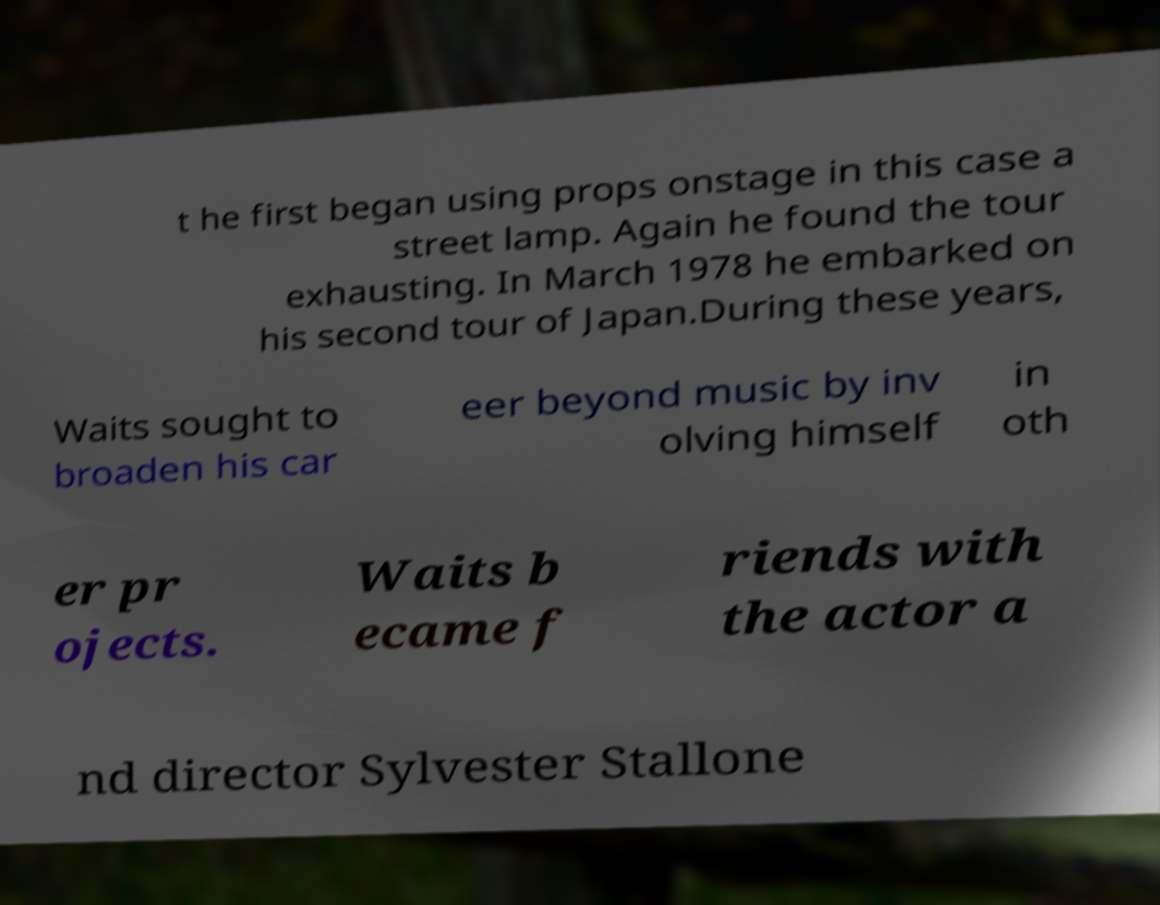For documentation purposes, I need the text within this image transcribed. Could you provide that? t he first began using props onstage in this case a street lamp. Again he found the tour exhausting. In March 1978 he embarked on his second tour of Japan.During these years, Waits sought to broaden his car eer beyond music by inv olving himself in oth er pr ojects. Waits b ecame f riends with the actor a nd director Sylvester Stallone 